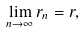<formula> <loc_0><loc_0><loc_500><loc_500>\lim _ { n \to \infty } r _ { n } = r ,</formula> 